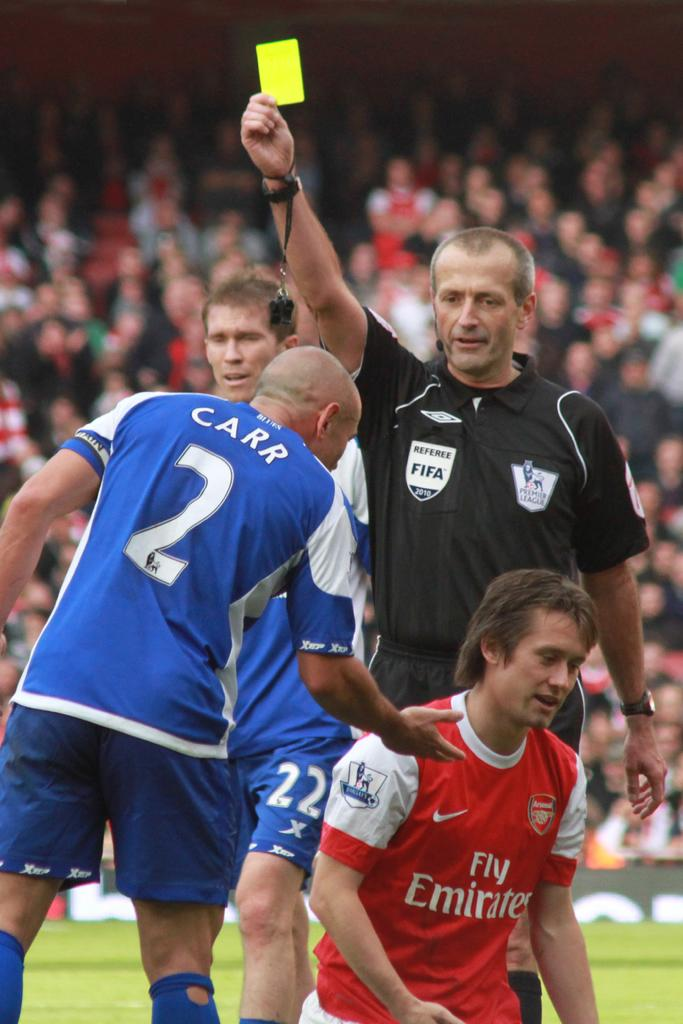<image>
Render a clear and concise summary of the photo. A referee from Fifa gives out a yellow card while player, Carr, puts his hand towards the opposing team member. 